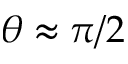<formula> <loc_0><loc_0><loc_500><loc_500>\theta \approx \pi / 2</formula> 